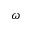<formula> <loc_0><loc_0><loc_500><loc_500>\omega</formula> 